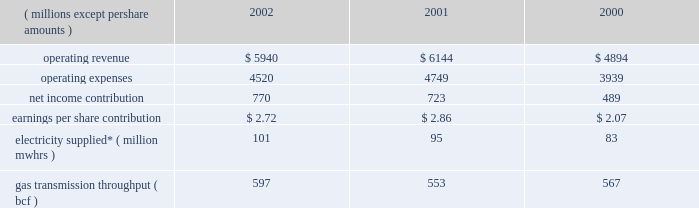Other taxes decreased in 2001 because its utility operations in virginia became subject to state income taxes in lieu of gross receipts taxes effective january 2001 .
In addition , dominion recognized higher effective rates for foreign earnings and higher pretax income in relation to non-conventional fuel tax credits realized .
Dominion energy 2002 2001 2000 ( millions , except per share amounts ) .
* amounts presented are for electricity supplied by utility and merchant generation operations .
Operating results 2014 2002 dominion energy contributed $ 2.72 per diluted share on net income of $ 770 million for 2002 , a net income increase of $ 47 million and an earnings per share decrease of $ 0.14 over 2001 .
Net income for 2002 reflected lower operating revenue ( $ 204 million ) , operating expenses ( $ 229 million ) and other income ( $ 27 million ) .
Interest expense and income taxes , which are discussed on a consolidated basis , decreased $ 50 million over 2001 .
The earnings per share decrease reflected share dilution .
Regulated electric sales revenue increased $ 179 million .
Favorable weather conditions , reflecting increased cooling and heating degree-days , as well as customer growth , are estimated to have contributed $ 133 million and $ 41 million , respectively .
Fuel rate recoveries increased approximately $ 65 million for 2002 .
These recoveries are generally offset by increases in elec- tric fuel expense and do not materially affect income .
Partially offsetting these increases was a net decrease of $ 60 million due to other factors not separately measurable , such as the impact of economic conditions on customer usage , as well as variations in seasonal rate premiums and discounts .
Nonregulated electric sales revenue increased $ 9 million .
Sales revenue from dominion 2019s merchant generation fleet decreased $ 21 million , reflecting a $ 201 million decline due to lower prices partially offset by sales from assets acquired and constructed in 2002 and the inclusion of millstone operations for all of 2002 .
Revenue from the wholesale marketing of utility generation decreased $ 74 million .
Due to the higher demand of utility service territory customers during 2002 , less production from utility plant generation was available for profitable sale in the wholesale market .
Revenue from retail energy sales increased $ 71 million , reflecting primarily customer growth over the prior year .
Net revenue from dominion 2019s electric trading activities increased $ 33 million , reflecting the effect of favorable price changes on unsettled contracts and higher trading margins .
Nonregulated gas sales revenue decreased $ 351 million .
The decrease included a $ 239 million decrease in sales by dominion 2019s field services and retail energy marketing opera- tions , reflecting to a large extent declining prices .
Revenue associated with gas trading operations , net of related cost of sales , decreased $ 112 million .
The decrease included $ 70 mil- lion of realized and unrealized losses on the economic hedges of natural gas production by the dominion exploration & pro- duction segment .
As described below under selected information 2014 energy trading activities , sales of natural gas by the dominion exploration & production segment at market prices offset these financial losses , resulting in a range of prices contemplated by dominion 2019s overall risk management strategy .
The remaining $ 42 million decrease was due to unfavorable price changes on unsettled contracts and lower overall trading margins .
Those losses were partially offset by contributions from higher trading volumes in gas and oil markets .
Gas transportation and storage revenue decreased $ 44 million , primarily reflecting lower rates .
Electric fuel and energy purchases expense increased $ 94 million which included an increase of $ 66 million associated with dominion 2019s energy marketing operations that are not sub- ject to cost-based rate regulation and an increase of $ 28 million associated with utility operations .
Substantially all of the increase associated with non-regulated energy marketing opera- tions related to higher volumes purchased during the year .
For utility operations , energy costs increased $ 66 million for pur- chases subject to rate recovery , partially offset by a $ 38 million decrease in fuel expenses associated with lower wholesale mar- keting of utility plant generation .
Purchased gas expense decreased $ 245 million associated with dominion 2019s field services and retail energy marketing oper- ations .
This decrease reflected approximately $ 162 million asso- ciated with declining prices and $ 83 million associated with lower purchased volumes .
Liquids , pipeline capacity and other purchases decreased $ 64 million , primarily reflecting comparably lower levels of rate recoveries of certain costs of transmission operations in the cur- rent year period .
The difference between actual expenses and amounts recovered in the period are deferred pending future rate adjustments .
Other operations and maintenance expense decreased $ 14 million , primarily reflecting an $ 18 million decrease in outage costs due to fewer generation unit outages in the current year .
Depreciation expense decreased $ 11 million , reflecting decreases in depreciation associated with changes in the esti- mated useful lives of certain electric generation property , par- tially offset by increased depreciation associated with state line and millstone operations .
Other income decreased $ 27 million , including a $ 14 mil- lion decrease in net realized investment gains in the millstone 37d o m i n i o n 2019 0 2 a n n u a l r e p o r t .
If the 2003 growth rate is the same as 2002 , what would 2003 gas transmission throughput be in bcf?\\n? 
Computations: ((597 / 553) * 597)
Answer: 644.5009. 